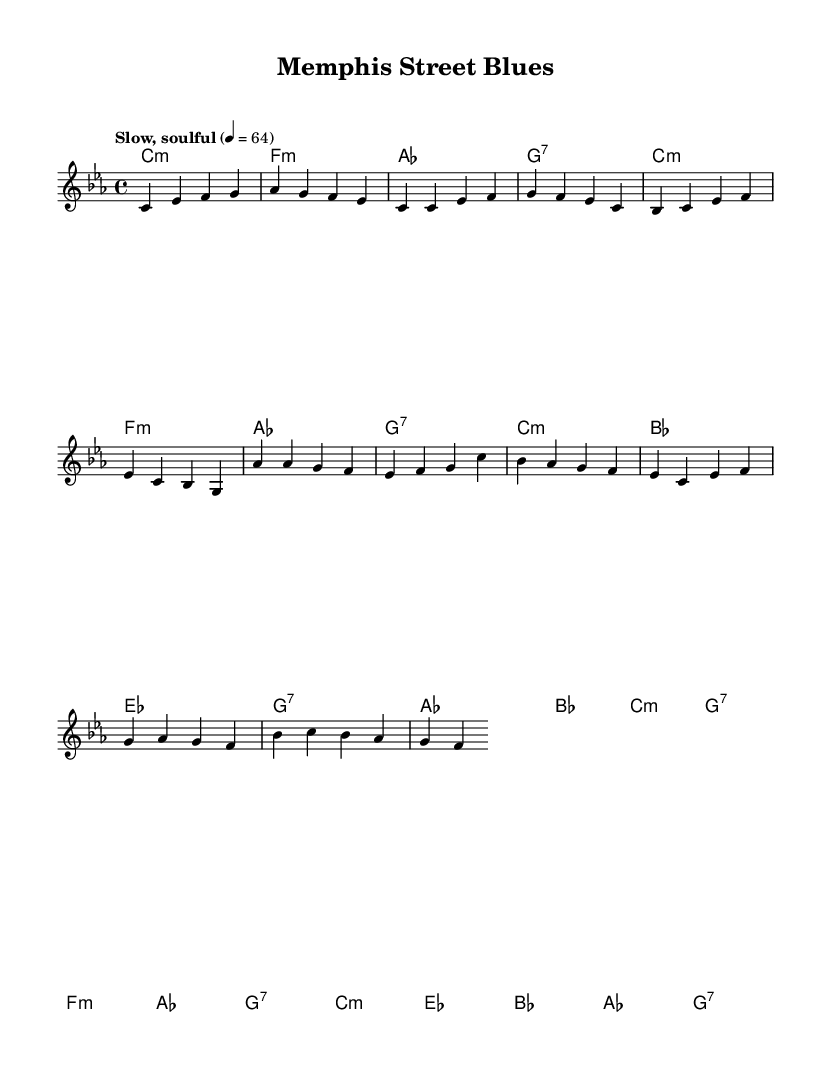What is the key signature of this music? The key signature is C minor, which contains three flats: B♭, E♭, and A♭. The presence of these flats indicates the tonality of the piece is in C minor.
Answer: C minor What is the time signature of the piece? The time signature shown in the music indicates a 4/4 measure, meaning there are four beats per measure and the quarter note gets one beat. This is typical for many soul music compositions.
Answer: 4/4 What is the tempo marking for the piece? The tempo marking indicates a slow, soulful feel with a metronome marking of 64 beats per minute, guiding how the piece is intended to be performed.
Answer: Slow, soulful 4 = 64 How many measures are in the intro section? By counting the measures in the intro from the given melody part, we find that there are four measures. Each measure aligns with the music notation for the intro section.
Answer: Four What chord follows A♭ in the chorus? In the chorus section, after the A♭ chord, the next chord is B♭. This can be observed by analyzing the sequence of chords listed under the chorus in the harmonies section.
Answer: B♭ What type of instruments are implied by the horn sections mentioned? The piece characteristically features brass instruments such as trumpets or saxophones, often found in soul music arrangements, particularly emphasizing the raw, gritty sound.
Answer: Brass What is the primary theme of the lyrics in soul music reflected in this piece? While there are no lyrics provided, soul music often explores themes of love, pain, and life experiences, typically conveyed through emotion-packed vocal performances and instrumental arrangements.
Answer: Emotion 